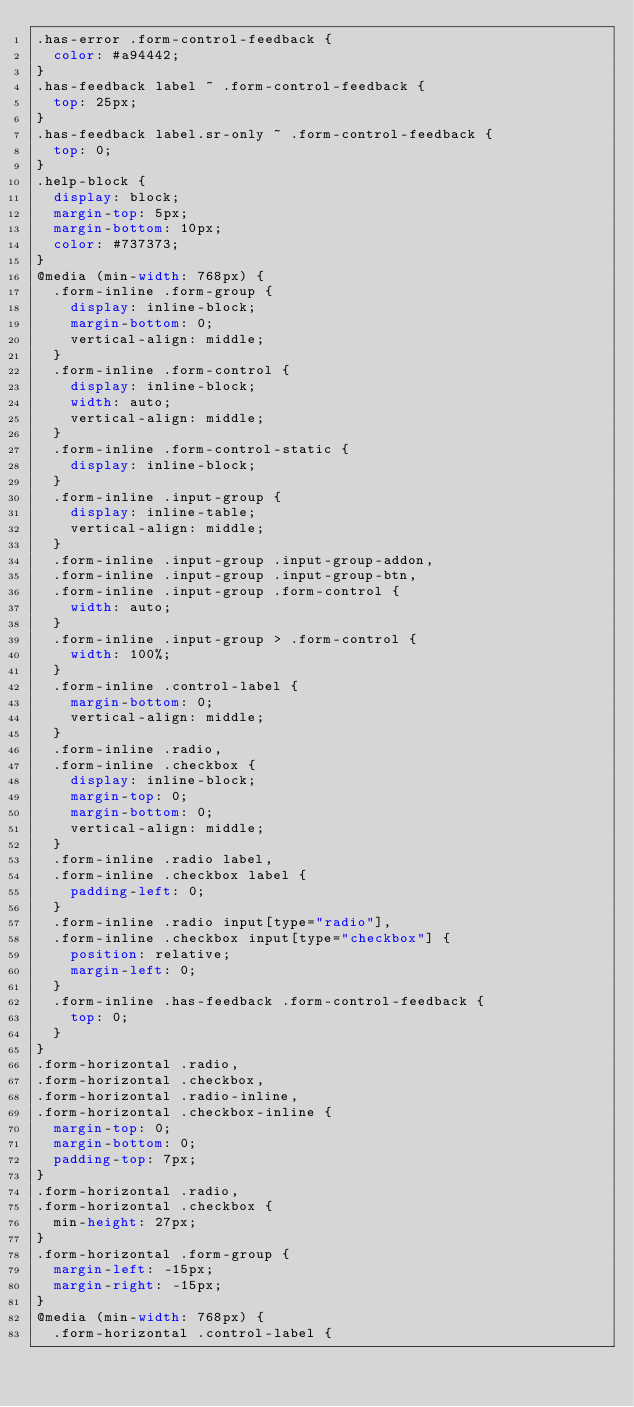<code> <loc_0><loc_0><loc_500><loc_500><_CSS_>.has-error .form-control-feedback {
  color: #a94442;
}
.has-feedback label ~ .form-control-feedback {
  top: 25px;
}
.has-feedback label.sr-only ~ .form-control-feedback {
  top: 0;
}
.help-block {
  display: block;
  margin-top: 5px;
  margin-bottom: 10px;
  color: #737373;
}
@media (min-width: 768px) {
  .form-inline .form-group {
    display: inline-block;
    margin-bottom: 0;
    vertical-align: middle;
  }
  .form-inline .form-control {
    display: inline-block;
    width: auto;
    vertical-align: middle;
  }
  .form-inline .form-control-static {
    display: inline-block;
  }
  .form-inline .input-group {
    display: inline-table;
    vertical-align: middle;
  }
  .form-inline .input-group .input-group-addon,
  .form-inline .input-group .input-group-btn,
  .form-inline .input-group .form-control {
    width: auto;
  }
  .form-inline .input-group > .form-control {
    width: 100%;
  }
  .form-inline .control-label {
    margin-bottom: 0;
    vertical-align: middle;
  }
  .form-inline .radio,
  .form-inline .checkbox {
    display: inline-block;
    margin-top: 0;
    margin-bottom: 0;
    vertical-align: middle;
  }
  .form-inline .radio label,
  .form-inline .checkbox label {
    padding-left: 0;
  }
  .form-inline .radio input[type="radio"],
  .form-inline .checkbox input[type="checkbox"] {
    position: relative;
    margin-left: 0;
  }
  .form-inline .has-feedback .form-control-feedback {
    top: 0;
  }
}
.form-horizontal .radio,
.form-horizontal .checkbox,
.form-horizontal .radio-inline,
.form-horizontal .checkbox-inline {
  margin-top: 0;
  margin-bottom: 0;
  padding-top: 7px;
}
.form-horizontal .radio,
.form-horizontal .checkbox {
  min-height: 27px;
}
.form-horizontal .form-group {
  margin-left: -15px;
  margin-right: -15px;
}
@media (min-width: 768px) {
  .form-horizontal .control-label {</code> 